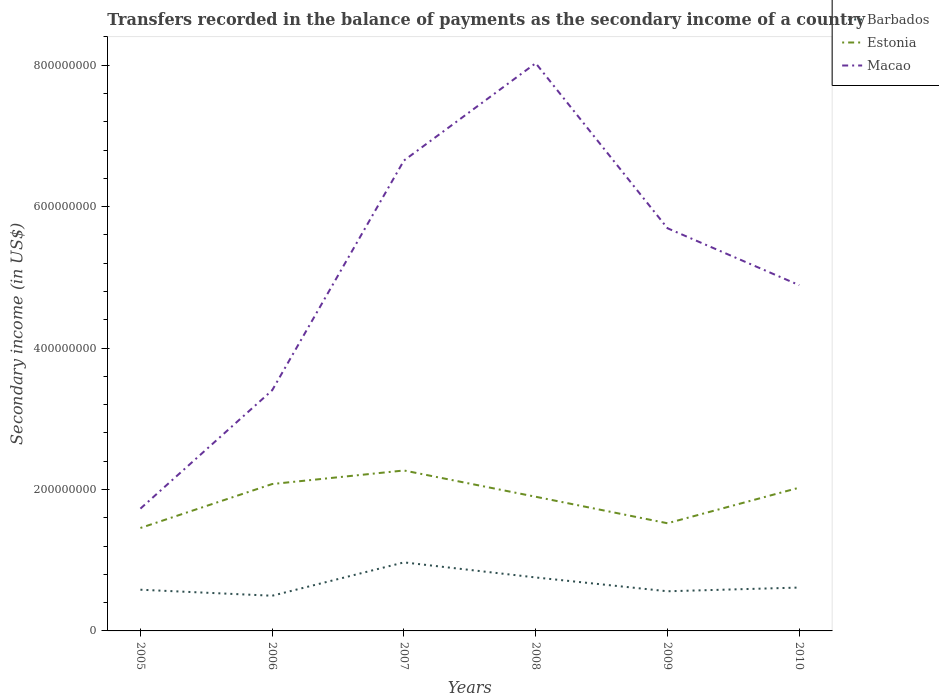How many different coloured lines are there?
Make the answer very short. 3. Is the number of lines equal to the number of legend labels?
Your answer should be compact. Yes. Across all years, what is the maximum secondary income of in Macao?
Ensure brevity in your answer.  1.73e+08. What is the total secondary income of in Estonia in the graph?
Your answer should be very brief. 5.55e+07. What is the difference between the highest and the second highest secondary income of in Barbados?
Offer a very short reply. 4.71e+07. How many lines are there?
Offer a very short reply. 3. How many years are there in the graph?
Provide a short and direct response. 6. What is the difference between two consecutive major ticks on the Y-axis?
Your answer should be very brief. 2.00e+08. Does the graph contain any zero values?
Provide a short and direct response. No. How many legend labels are there?
Provide a short and direct response. 3. What is the title of the graph?
Your answer should be compact. Transfers recorded in the balance of payments as the secondary income of a country. What is the label or title of the X-axis?
Your response must be concise. Years. What is the label or title of the Y-axis?
Keep it short and to the point. Secondary income (in US$). What is the Secondary income (in US$) in Barbados in 2005?
Your answer should be very brief. 5.83e+07. What is the Secondary income (in US$) of Estonia in 2005?
Your answer should be very brief. 1.46e+08. What is the Secondary income (in US$) of Macao in 2005?
Keep it short and to the point. 1.73e+08. What is the Secondary income (in US$) in Barbados in 2006?
Your response must be concise. 4.97e+07. What is the Secondary income (in US$) of Estonia in 2006?
Offer a very short reply. 2.08e+08. What is the Secondary income (in US$) of Macao in 2006?
Ensure brevity in your answer.  3.40e+08. What is the Secondary income (in US$) of Barbados in 2007?
Provide a succinct answer. 9.69e+07. What is the Secondary income (in US$) in Estonia in 2007?
Your answer should be very brief. 2.27e+08. What is the Secondary income (in US$) of Macao in 2007?
Ensure brevity in your answer.  6.65e+08. What is the Secondary income (in US$) in Barbados in 2008?
Provide a short and direct response. 7.56e+07. What is the Secondary income (in US$) in Estonia in 2008?
Ensure brevity in your answer.  1.90e+08. What is the Secondary income (in US$) in Macao in 2008?
Keep it short and to the point. 8.03e+08. What is the Secondary income (in US$) of Barbados in 2009?
Offer a very short reply. 5.61e+07. What is the Secondary income (in US$) of Estonia in 2009?
Make the answer very short. 1.52e+08. What is the Secondary income (in US$) in Macao in 2009?
Your response must be concise. 5.69e+08. What is the Secondary income (in US$) of Barbados in 2010?
Provide a succinct answer. 6.13e+07. What is the Secondary income (in US$) of Estonia in 2010?
Offer a terse response. 2.03e+08. What is the Secondary income (in US$) in Macao in 2010?
Your answer should be compact. 4.89e+08. Across all years, what is the maximum Secondary income (in US$) in Barbados?
Give a very brief answer. 9.69e+07. Across all years, what is the maximum Secondary income (in US$) of Estonia?
Your response must be concise. 2.27e+08. Across all years, what is the maximum Secondary income (in US$) in Macao?
Offer a very short reply. 8.03e+08. Across all years, what is the minimum Secondary income (in US$) in Barbados?
Your answer should be very brief. 4.97e+07. Across all years, what is the minimum Secondary income (in US$) in Estonia?
Offer a very short reply. 1.46e+08. Across all years, what is the minimum Secondary income (in US$) of Macao?
Provide a succinct answer. 1.73e+08. What is the total Secondary income (in US$) in Barbados in the graph?
Provide a succinct answer. 3.98e+08. What is the total Secondary income (in US$) of Estonia in the graph?
Offer a terse response. 1.12e+09. What is the total Secondary income (in US$) of Macao in the graph?
Give a very brief answer. 3.04e+09. What is the difference between the Secondary income (in US$) of Barbados in 2005 and that in 2006?
Ensure brevity in your answer.  8.51e+06. What is the difference between the Secondary income (in US$) in Estonia in 2005 and that in 2006?
Provide a succinct answer. -6.21e+07. What is the difference between the Secondary income (in US$) of Macao in 2005 and that in 2006?
Make the answer very short. -1.67e+08. What is the difference between the Secondary income (in US$) in Barbados in 2005 and that in 2007?
Ensure brevity in your answer.  -3.86e+07. What is the difference between the Secondary income (in US$) in Estonia in 2005 and that in 2007?
Your response must be concise. -8.13e+07. What is the difference between the Secondary income (in US$) in Macao in 2005 and that in 2007?
Ensure brevity in your answer.  -4.92e+08. What is the difference between the Secondary income (in US$) of Barbados in 2005 and that in 2008?
Ensure brevity in your answer.  -1.73e+07. What is the difference between the Secondary income (in US$) of Estonia in 2005 and that in 2008?
Keep it short and to the point. -4.41e+07. What is the difference between the Secondary income (in US$) of Macao in 2005 and that in 2008?
Offer a terse response. -6.30e+08. What is the difference between the Secondary income (in US$) in Barbados in 2005 and that in 2009?
Your response must be concise. 2.20e+06. What is the difference between the Secondary income (in US$) in Estonia in 2005 and that in 2009?
Provide a short and direct response. -6.67e+06. What is the difference between the Secondary income (in US$) in Macao in 2005 and that in 2009?
Provide a short and direct response. -3.96e+08. What is the difference between the Secondary income (in US$) in Barbados in 2005 and that in 2010?
Your answer should be very brief. -3.06e+06. What is the difference between the Secondary income (in US$) in Estonia in 2005 and that in 2010?
Provide a short and direct response. -5.70e+07. What is the difference between the Secondary income (in US$) in Macao in 2005 and that in 2010?
Give a very brief answer. -3.16e+08. What is the difference between the Secondary income (in US$) in Barbados in 2006 and that in 2007?
Give a very brief answer. -4.71e+07. What is the difference between the Secondary income (in US$) in Estonia in 2006 and that in 2007?
Your answer should be very brief. -1.92e+07. What is the difference between the Secondary income (in US$) in Macao in 2006 and that in 2007?
Your response must be concise. -3.25e+08. What is the difference between the Secondary income (in US$) of Barbados in 2006 and that in 2008?
Ensure brevity in your answer.  -2.58e+07. What is the difference between the Secondary income (in US$) in Estonia in 2006 and that in 2008?
Keep it short and to the point. 1.80e+07. What is the difference between the Secondary income (in US$) in Macao in 2006 and that in 2008?
Your answer should be compact. -4.62e+08. What is the difference between the Secondary income (in US$) in Barbados in 2006 and that in 2009?
Provide a succinct answer. -6.32e+06. What is the difference between the Secondary income (in US$) of Estonia in 2006 and that in 2009?
Offer a very short reply. 5.55e+07. What is the difference between the Secondary income (in US$) of Macao in 2006 and that in 2009?
Provide a succinct answer. -2.29e+08. What is the difference between the Secondary income (in US$) in Barbados in 2006 and that in 2010?
Make the answer very short. -1.16e+07. What is the difference between the Secondary income (in US$) in Estonia in 2006 and that in 2010?
Provide a short and direct response. 5.15e+06. What is the difference between the Secondary income (in US$) of Macao in 2006 and that in 2010?
Offer a very short reply. -1.49e+08. What is the difference between the Secondary income (in US$) of Barbados in 2007 and that in 2008?
Offer a very short reply. 2.13e+07. What is the difference between the Secondary income (in US$) of Estonia in 2007 and that in 2008?
Ensure brevity in your answer.  3.72e+07. What is the difference between the Secondary income (in US$) in Macao in 2007 and that in 2008?
Provide a succinct answer. -1.38e+08. What is the difference between the Secondary income (in US$) in Barbados in 2007 and that in 2009?
Give a very brief answer. 4.08e+07. What is the difference between the Secondary income (in US$) in Estonia in 2007 and that in 2009?
Your answer should be very brief. 7.46e+07. What is the difference between the Secondary income (in US$) of Macao in 2007 and that in 2009?
Your answer should be compact. 9.57e+07. What is the difference between the Secondary income (in US$) of Barbados in 2007 and that in 2010?
Keep it short and to the point. 3.56e+07. What is the difference between the Secondary income (in US$) of Estonia in 2007 and that in 2010?
Provide a short and direct response. 2.43e+07. What is the difference between the Secondary income (in US$) of Macao in 2007 and that in 2010?
Your answer should be compact. 1.76e+08. What is the difference between the Secondary income (in US$) of Barbados in 2008 and that in 2009?
Your response must be concise. 1.95e+07. What is the difference between the Secondary income (in US$) in Estonia in 2008 and that in 2009?
Your response must be concise. 3.75e+07. What is the difference between the Secondary income (in US$) in Macao in 2008 and that in 2009?
Ensure brevity in your answer.  2.33e+08. What is the difference between the Secondary income (in US$) of Barbados in 2008 and that in 2010?
Offer a terse response. 1.43e+07. What is the difference between the Secondary income (in US$) of Estonia in 2008 and that in 2010?
Keep it short and to the point. -1.28e+07. What is the difference between the Secondary income (in US$) in Macao in 2008 and that in 2010?
Provide a short and direct response. 3.14e+08. What is the difference between the Secondary income (in US$) in Barbados in 2009 and that in 2010?
Keep it short and to the point. -5.26e+06. What is the difference between the Secondary income (in US$) in Estonia in 2009 and that in 2010?
Give a very brief answer. -5.03e+07. What is the difference between the Secondary income (in US$) in Macao in 2009 and that in 2010?
Provide a succinct answer. 8.05e+07. What is the difference between the Secondary income (in US$) in Barbados in 2005 and the Secondary income (in US$) in Estonia in 2006?
Your response must be concise. -1.49e+08. What is the difference between the Secondary income (in US$) in Barbados in 2005 and the Secondary income (in US$) in Macao in 2006?
Your response must be concise. -2.82e+08. What is the difference between the Secondary income (in US$) in Estonia in 2005 and the Secondary income (in US$) in Macao in 2006?
Make the answer very short. -1.95e+08. What is the difference between the Secondary income (in US$) in Barbados in 2005 and the Secondary income (in US$) in Estonia in 2007?
Make the answer very short. -1.69e+08. What is the difference between the Secondary income (in US$) of Barbados in 2005 and the Secondary income (in US$) of Macao in 2007?
Your response must be concise. -6.07e+08. What is the difference between the Secondary income (in US$) of Estonia in 2005 and the Secondary income (in US$) of Macao in 2007?
Provide a short and direct response. -5.20e+08. What is the difference between the Secondary income (in US$) in Barbados in 2005 and the Secondary income (in US$) in Estonia in 2008?
Your response must be concise. -1.31e+08. What is the difference between the Secondary income (in US$) of Barbados in 2005 and the Secondary income (in US$) of Macao in 2008?
Provide a short and direct response. -7.44e+08. What is the difference between the Secondary income (in US$) of Estonia in 2005 and the Secondary income (in US$) of Macao in 2008?
Keep it short and to the point. -6.57e+08. What is the difference between the Secondary income (in US$) in Barbados in 2005 and the Secondary income (in US$) in Estonia in 2009?
Provide a short and direct response. -9.40e+07. What is the difference between the Secondary income (in US$) of Barbados in 2005 and the Secondary income (in US$) of Macao in 2009?
Give a very brief answer. -5.11e+08. What is the difference between the Secondary income (in US$) of Estonia in 2005 and the Secondary income (in US$) of Macao in 2009?
Make the answer very short. -4.24e+08. What is the difference between the Secondary income (in US$) of Barbados in 2005 and the Secondary income (in US$) of Estonia in 2010?
Keep it short and to the point. -1.44e+08. What is the difference between the Secondary income (in US$) of Barbados in 2005 and the Secondary income (in US$) of Macao in 2010?
Your answer should be compact. -4.31e+08. What is the difference between the Secondary income (in US$) in Estonia in 2005 and the Secondary income (in US$) in Macao in 2010?
Your response must be concise. -3.43e+08. What is the difference between the Secondary income (in US$) in Barbados in 2006 and the Secondary income (in US$) in Estonia in 2007?
Offer a very short reply. -1.77e+08. What is the difference between the Secondary income (in US$) in Barbados in 2006 and the Secondary income (in US$) in Macao in 2007?
Make the answer very short. -6.15e+08. What is the difference between the Secondary income (in US$) of Estonia in 2006 and the Secondary income (in US$) of Macao in 2007?
Your answer should be compact. -4.57e+08. What is the difference between the Secondary income (in US$) of Barbados in 2006 and the Secondary income (in US$) of Estonia in 2008?
Offer a terse response. -1.40e+08. What is the difference between the Secondary income (in US$) of Barbados in 2006 and the Secondary income (in US$) of Macao in 2008?
Ensure brevity in your answer.  -7.53e+08. What is the difference between the Secondary income (in US$) in Estonia in 2006 and the Secondary income (in US$) in Macao in 2008?
Your answer should be compact. -5.95e+08. What is the difference between the Secondary income (in US$) of Barbados in 2006 and the Secondary income (in US$) of Estonia in 2009?
Your response must be concise. -1.02e+08. What is the difference between the Secondary income (in US$) of Barbados in 2006 and the Secondary income (in US$) of Macao in 2009?
Provide a short and direct response. -5.20e+08. What is the difference between the Secondary income (in US$) of Estonia in 2006 and the Secondary income (in US$) of Macao in 2009?
Your answer should be very brief. -3.62e+08. What is the difference between the Secondary income (in US$) of Barbados in 2006 and the Secondary income (in US$) of Estonia in 2010?
Keep it short and to the point. -1.53e+08. What is the difference between the Secondary income (in US$) in Barbados in 2006 and the Secondary income (in US$) in Macao in 2010?
Offer a terse response. -4.39e+08. What is the difference between the Secondary income (in US$) of Estonia in 2006 and the Secondary income (in US$) of Macao in 2010?
Keep it short and to the point. -2.81e+08. What is the difference between the Secondary income (in US$) of Barbados in 2007 and the Secondary income (in US$) of Estonia in 2008?
Offer a very short reply. -9.28e+07. What is the difference between the Secondary income (in US$) of Barbados in 2007 and the Secondary income (in US$) of Macao in 2008?
Offer a terse response. -7.06e+08. What is the difference between the Secondary income (in US$) of Estonia in 2007 and the Secondary income (in US$) of Macao in 2008?
Give a very brief answer. -5.76e+08. What is the difference between the Secondary income (in US$) of Barbados in 2007 and the Secondary income (in US$) of Estonia in 2009?
Make the answer very short. -5.53e+07. What is the difference between the Secondary income (in US$) in Barbados in 2007 and the Secondary income (in US$) in Macao in 2009?
Offer a terse response. -4.72e+08. What is the difference between the Secondary income (in US$) in Estonia in 2007 and the Secondary income (in US$) in Macao in 2009?
Provide a short and direct response. -3.43e+08. What is the difference between the Secondary income (in US$) of Barbados in 2007 and the Secondary income (in US$) of Estonia in 2010?
Your answer should be very brief. -1.06e+08. What is the difference between the Secondary income (in US$) in Barbados in 2007 and the Secondary income (in US$) in Macao in 2010?
Your response must be concise. -3.92e+08. What is the difference between the Secondary income (in US$) in Estonia in 2007 and the Secondary income (in US$) in Macao in 2010?
Ensure brevity in your answer.  -2.62e+08. What is the difference between the Secondary income (in US$) in Barbados in 2008 and the Secondary income (in US$) in Estonia in 2009?
Make the answer very short. -7.66e+07. What is the difference between the Secondary income (in US$) in Barbados in 2008 and the Secondary income (in US$) in Macao in 2009?
Make the answer very short. -4.94e+08. What is the difference between the Secondary income (in US$) of Estonia in 2008 and the Secondary income (in US$) of Macao in 2009?
Your answer should be very brief. -3.80e+08. What is the difference between the Secondary income (in US$) of Barbados in 2008 and the Secondary income (in US$) of Estonia in 2010?
Ensure brevity in your answer.  -1.27e+08. What is the difference between the Secondary income (in US$) in Barbados in 2008 and the Secondary income (in US$) in Macao in 2010?
Provide a succinct answer. -4.13e+08. What is the difference between the Secondary income (in US$) of Estonia in 2008 and the Secondary income (in US$) of Macao in 2010?
Make the answer very short. -2.99e+08. What is the difference between the Secondary income (in US$) of Barbados in 2009 and the Secondary income (in US$) of Estonia in 2010?
Offer a terse response. -1.46e+08. What is the difference between the Secondary income (in US$) in Barbados in 2009 and the Secondary income (in US$) in Macao in 2010?
Provide a succinct answer. -4.33e+08. What is the difference between the Secondary income (in US$) in Estonia in 2009 and the Secondary income (in US$) in Macao in 2010?
Give a very brief answer. -3.37e+08. What is the average Secondary income (in US$) in Barbados per year?
Provide a succinct answer. 6.63e+07. What is the average Secondary income (in US$) of Estonia per year?
Offer a terse response. 1.87e+08. What is the average Secondary income (in US$) of Macao per year?
Provide a short and direct response. 5.07e+08. In the year 2005, what is the difference between the Secondary income (in US$) in Barbados and Secondary income (in US$) in Estonia?
Ensure brevity in your answer.  -8.73e+07. In the year 2005, what is the difference between the Secondary income (in US$) in Barbados and Secondary income (in US$) in Macao?
Make the answer very short. -1.15e+08. In the year 2005, what is the difference between the Secondary income (in US$) of Estonia and Secondary income (in US$) of Macao?
Offer a very short reply. -2.74e+07. In the year 2006, what is the difference between the Secondary income (in US$) of Barbados and Secondary income (in US$) of Estonia?
Keep it short and to the point. -1.58e+08. In the year 2006, what is the difference between the Secondary income (in US$) of Barbados and Secondary income (in US$) of Macao?
Offer a terse response. -2.91e+08. In the year 2006, what is the difference between the Secondary income (in US$) of Estonia and Secondary income (in US$) of Macao?
Give a very brief answer. -1.33e+08. In the year 2007, what is the difference between the Secondary income (in US$) of Barbados and Secondary income (in US$) of Estonia?
Keep it short and to the point. -1.30e+08. In the year 2007, what is the difference between the Secondary income (in US$) in Barbados and Secondary income (in US$) in Macao?
Provide a short and direct response. -5.68e+08. In the year 2007, what is the difference between the Secondary income (in US$) in Estonia and Secondary income (in US$) in Macao?
Offer a terse response. -4.38e+08. In the year 2008, what is the difference between the Secondary income (in US$) of Barbados and Secondary income (in US$) of Estonia?
Provide a succinct answer. -1.14e+08. In the year 2008, what is the difference between the Secondary income (in US$) of Barbados and Secondary income (in US$) of Macao?
Ensure brevity in your answer.  -7.27e+08. In the year 2008, what is the difference between the Secondary income (in US$) in Estonia and Secondary income (in US$) in Macao?
Your answer should be very brief. -6.13e+08. In the year 2009, what is the difference between the Secondary income (in US$) in Barbados and Secondary income (in US$) in Estonia?
Make the answer very short. -9.62e+07. In the year 2009, what is the difference between the Secondary income (in US$) of Barbados and Secondary income (in US$) of Macao?
Provide a succinct answer. -5.13e+08. In the year 2009, what is the difference between the Secondary income (in US$) of Estonia and Secondary income (in US$) of Macao?
Your response must be concise. -4.17e+08. In the year 2010, what is the difference between the Secondary income (in US$) in Barbados and Secondary income (in US$) in Estonia?
Keep it short and to the point. -1.41e+08. In the year 2010, what is the difference between the Secondary income (in US$) of Barbados and Secondary income (in US$) of Macao?
Make the answer very short. -4.28e+08. In the year 2010, what is the difference between the Secondary income (in US$) of Estonia and Secondary income (in US$) of Macao?
Offer a very short reply. -2.86e+08. What is the ratio of the Secondary income (in US$) of Barbados in 2005 to that in 2006?
Make the answer very short. 1.17. What is the ratio of the Secondary income (in US$) of Estonia in 2005 to that in 2006?
Provide a succinct answer. 0.7. What is the ratio of the Secondary income (in US$) of Macao in 2005 to that in 2006?
Offer a terse response. 0.51. What is the ratio of the Secondary income (in US$) of Barbados in 2005 to that in 2007?
Give a very brief answer. 0.6. What is the ratio of the Secondary income (in US$) in Estonia in 2005 to that in 2007?
Provide a succinct answer. 0.64. What is the ratio of the Secondary income (in US$) in Macao in 2005 to that in 2007?
Ensure brevity in your answer.  0.26. What is the ratio of the Secondary income (in US$) in Barbados in 2005 to that in 2008?
Ensure brevity in your answer.  0.77. What is the ratio of the Secondary income (in US$) in Estonia in 2005 to that in 2008?
Provide a short and direct response. 0.77. What is the ratio of the Secondary income (in US$) of Macao in 2005 to that in 2008?
Make the answer very short. 0.22. What is the ratio of the Secondary income (in US$) in Barbados in 2005 to that in 2009?
Your answer should be compact. 1.04. What is the ratio of the Secondary income (in US$) of Estonia in 2005 to that in 2009?
Make the answer very short. 0.96. What is the ratio of the Secondary income (in US$) in Macao in 2005 to that in 2009?
Ensure brevity in your answer.  0.3. What is the ratio of the Secondary income (in US$) of Barbados in 2005 to that in 2010?
Ensure brevity in your answer.  0.95. What is the ratio of the Secondary income (in US$) in Estonia in 2005 to that in 2010?
Ensure brevity in your answer.  0.72. What is the ratio of the Secondary income (in US$) of Macao in 2005 to that in 2010?
Offer a very short reply. 0.35. What is the ratio of the Secondary income (in US$) in Barbados in 2006 to that in 2007?
Your answer should be compact. 0.51. What is the ratio of the Secondary income (in US$) in Estonia in 2006 to that in 2007?
Give a very brief answer. 0.92. What is the ratio of the Secondary income (in US$) of Macao in 2006 to that in 2007?
Offer a terse response. 0.51. What is the ratio of the Secondary income (in US$) in Barbados in 2006 to that in 2008?
Provide a short and direct response. 0.66. What is the ratio of the Secondary income (in US$) of Estonia in 2006 to that in 2008?
Ensure brevity in your answer.  1.09. What is the ratio of the Secondary income (in US$) of Macao in 2006 to that in 2008?
Make the answer very short. 0.42. What is the ratio of the Secondary income (in US$) in Barbados in 2006 to that in 2009?
Offer a terse response. 0.89. What is the ratio of the Secondary income (in US$) of Estonia in 2006 to that in 2009?
Keep it short and to the point. 1.36. What is the ratio of the Secondary income (in US$) in Macao in 2006 to that in 2009?
Provide a short and direct response. 0.6. What is the ratio of the Secondary income (in US$) in Barbados in 2006 to that in 2010?
Offer a terse response. 0.81. What is the ratio of the Secondary income (in US$) in Estonia in 2006 to that in 2010?
Provide a short and direct response. 1.03. What is the ratio of the Secondary income (in US$) of Macao in 2006 to that in 2010?
Your answer should be compact. 0.7. What is the ratio of the Secondary income (in US$) in Barbados in 2007 to that in 2008?
Your response must be concise. 1.28. What is the ratio of the Secondary income (in US$) of Estonia in 2007 to that in 2008?
Provide a succinct answer. 1.2. What is the ratio of the Secondary income (in US$) in Macao in 2007 to that in 2008?
Offer a very short reply. 0.83. What is the ratio of the Secondary income (in US$) of Barbados in 2007 to that in 2009?
Provide a succinct answer. 1.73. What is the ratio of the Secondary income (in US$) in Estonia in 2007 to that in 2009?
Provide a short and direct response. 1.49. What is the ratio of the Secondary income (in US$) in Macao in 2007 to that in 2009?
Make the answer very short. 1.17. What is the ratio of the Secondary income (in US$) of Barbados in 2007 to that in 2010?
Provide a succinct answer. 1.58. What is the ratio of the Secondary income (in US$) in Estonia in 2007 to that in 2010?
Offer a very short reply. 1.12. What is the ratio of the Secondary income (in US$) of Macao in 2007 to that in 2010?
Your answer should be compact. 1.36. What is the ratio of the Secondary income (in US$) of Barbados in 2008 to that in 2009?
Keep it short and to the point. 1.35. What is the ratio of the Secondary income (in US$) of Estonia in 2008 to that in 2009?
Your answer should be very brief. 1.25. What is the ratio of the Secondary income (in US$) of Macao in 2008 to that in 2009?
Offer a very short reply. 1.41. What is the ratio of the Secondary income (in US$) of Barbados in 2008 to that in 2010?
Your answer should be compact. 1.23. What is the ratio of the Secondary income (in US$) in Estonia in 2008 to that in 2010?
Provide a succinct answer. 0.94. What is the ratio of the Secondary income (in US$) of Macao in 2008 to that in 2010?
Provide a short and direct response. 1.64. What is the ratio of the Secondary income (in US$) of Barbados in 2009 to that in 2010?
Make the answer very short. 0.91. What is the ratio of the Secondary income (in US$) of Estonia in 2009 to that in 2010?
Ensure brevity in your answer.  0.75. What is the ratio of the Secondary income (in US$) of Macao in 2009 to that in 2010?
Your answer should be compact. 1.16. What is the difference between the highest and the second highest Secondary income (in US$) of Barbados?
Make the answer very short. 2.13e+07. What is the difference between the highest and the second highest Secondary income (in US$) in Estonia?
Keep it short and to the point. 1.92e+07. What is the difference between the highest and the second highest Secondary income (in US$) of Macao?
Your answer should be very brief. 1.38e+08. What is the difference between the highest and the lowest Secondary income (in US$) in Barbados?
Ensure brevity in your answer.  4.71e+07. What is the difference between the highest and the lowest Secondary income (in US$) of Estonia?
Offer a very short reply. 8.13e+07. What is the difference between the highest and the lowest Secondary income (in US$) in Macao?
Offer a terse response. 6.30e+08. 